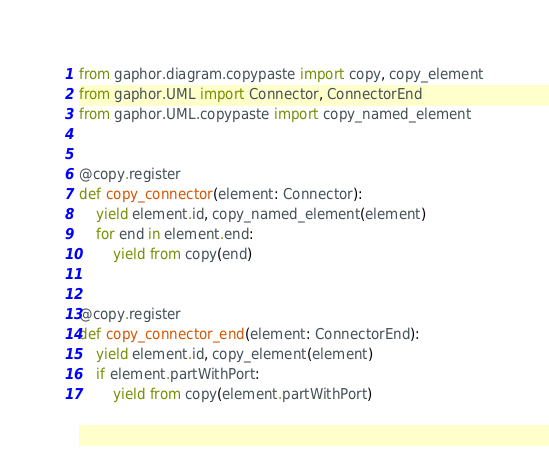<code> <loc_0><loc_0><loc_500><loc_500><_Python_>from gaphor.diagram.copypaste import copy, copy_element
from gaphor.UML import Connector, ConnectorEnd
from gaphor.UML.copypaste import copy_named_element


@copy.register
def copy_connector(element: Connector):
    yield element.id, copy_named_element(element)
    for end in element.end:
        yield from copy(end)


@copy.register
def copy_connector_end(element: ConnectorEnd):
    yield element.id, copy_element(element)
    if element.partWithPort:
        yield from copy(element.partWithPort)
</code> 